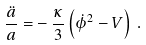Convert formula to latex. <formula><loc_0><loc_0><loc_500><loc_500>\frac { \ddot { a } } { a } = - \, \frac { \kappa } { 3 } \left ( { \dot { \phi } } ^ { 2 } - V \right ) \, .</formula> 